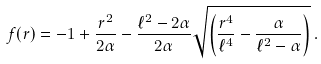Convert formula to latex. <formula><loc_0><loc_0><loc_500><loc_500>f ( r ) = - 1 + \frac { r ^ { 2 } } { 2 \alpha } - \frac { { \ell } ^ { 2 } - 2 \alpha } { 2 \alpha } \sqrt { \left ( \frac { r ^ { 4 } } { { \ell } ^ { 4 } } - \frac { \alpha } { { \ell } ^ { 2 } - \alpha } \right ) } \, .</formula> 